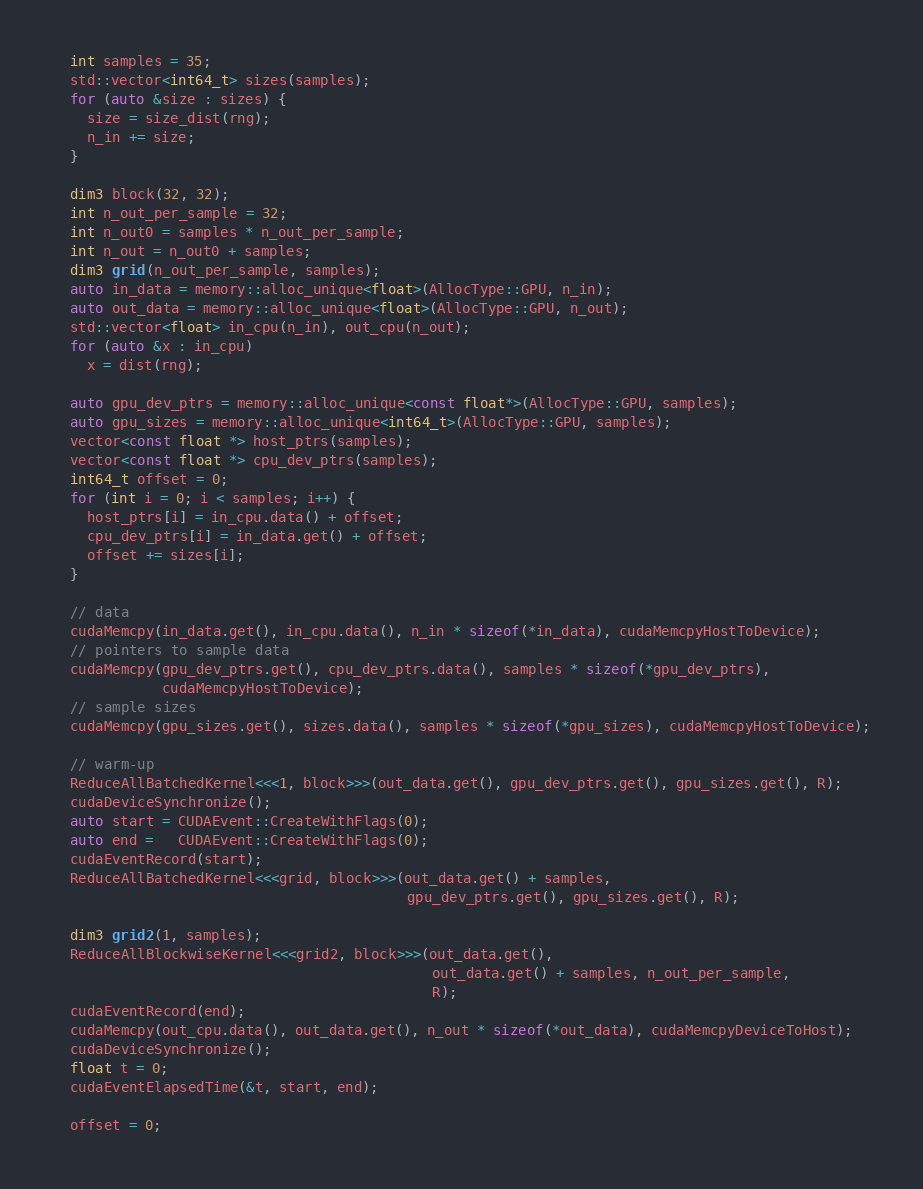<code> <loc_0><loc_0><loc_500><loc_500><_Cuda_>  int samples = 35;
  std::vector<int64_t> sizes(samples);
  for (auto &size : sizes) {
    size = size_dist(rng);
    n_in += size;
  }

  dim3 block(32, 32);
  int n_out_per_sample = 32;
  int n_out0 = samples * n_out_per_sample;
  int n_out = n_out0 + samples;
  dim3 grid(n_out_per_sample, samples);
  auto in_data = memory::alloc_unique<float>(AllocType::GPU, n_in);
  auto out_data = memory::alloc_unique<float>(AllocType::GPU, n_out);
  std::vector<float> in_cpu(n_in), out_cpu(n_out);
  for (auto &x : in_cpu)
    x = dist(rng);

  auto gpu_dev_ptrs = memory::alloc_unique<const float*>(AllocType::GPU, samples);
  auto gpu_sizes = memory::alloc_unique<int64_t>(AllocType::GPU, samples);
  vector<const float *> host_ptrs(samples);
  vector<const float *> cpu_dev_ptrs(samples);
  int64_t offset = 0;
  for (int i = 0; i < samples; i++) {
    host_ptrs[i] = in_cpu.data() + offset;
    cpu_dev_ptrs[i] = in_data.get() + offset;
    offset += sizes[i];
  }

  // data
  cudaMemcpy(in_data.get(), in_cpu.data(), n_in * sizeof(*in_data), cudaMemcpyHostToDevice);
  // pointers to sample data
  cudaMemcpy(gpu_dev_ptrs.get(), cpu_dev_ptrs.data(), samples * sizeof(*gpu_dev_ptrs),
             cudaMemcpyHostToDevice);
  // sample sizes
  cudaMemcpy(gpu_sizes.get(), sizes.data(), samples * sizeof(*gpu_sizes), cudaMemcpyHostToDevice);

  // warm-up
  ReduceAllBatchedKernel<<<1, block>>>(out_data.get(), gpu_dev_ptrs.get(), gpu_sizes.get(), R);
  cudaDeviceSynchronize();
  auto start = CUDAEvent::CreateWithFlags(0);
  auto end =   CUDAEvent::CreateWithFlags(0);
  cudaEventRecord(start);
  ReduceAllBatchedKernel<<<grid, block>>>(out_data.get() + samples,
                                          gpu_dev_ptrs.get(), gpu_sizes.get(), R);

  dim3 grid2(1, samples);
  ReduceAllBlockwiseKernel<<<grid2, block>>>(out_data.get(),
                                             out_data.get() + samples, n_out_per_sample,
                                             R);
  cudaEventRecord(end);
  cudaMemcpy(out_cpu.data(), out_data.get(), n_out * sizeof(*out_data), cudaMemcpyDeviceToHost);
  cudaDeviceSynchronize();
  float t = 0;
  cudaEventElapsedTime(&t, start, end);

  offset = 0;</code> 